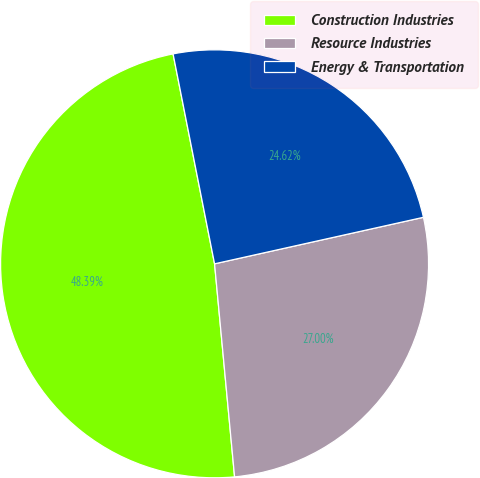<chart> <loc_0><loc_0><loc_500><loc_500><pie_chart><fcel>Construction Industries<fcel>Resource Industries<fcel>Energy & Transportation<nl><fcel>48.39%<fcel>27.0%<fcel>24.62%<nl></chart> 